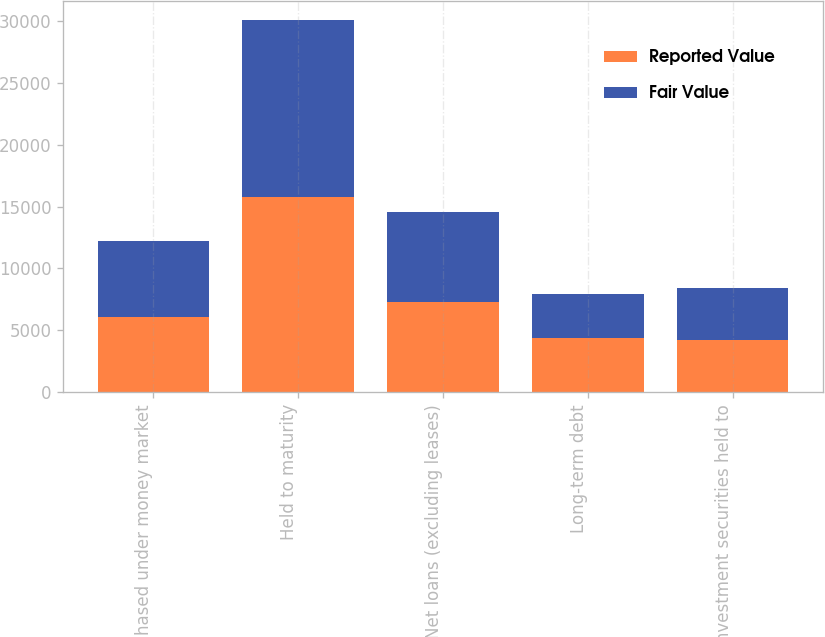Convert chart. <chart><loc_0><loc_0><loc_500><loc_500><stacked_bar_chart><ecel><fcel>Purchased under money market<fcel>Held to maturity<fcel>Net loans (excluding leases)<fcel>Long-term debt<fcel>Investment securities held to<nl><fcel>Reported Value<fcel>6087<fcel>15767<fcel>7269<fcel>4419<fcel>4233<nl><fcel>Fair Value<fcel>6101<fcel>14311<fcel>7269<fcel>3510<fcel>4225<nl></chart> 